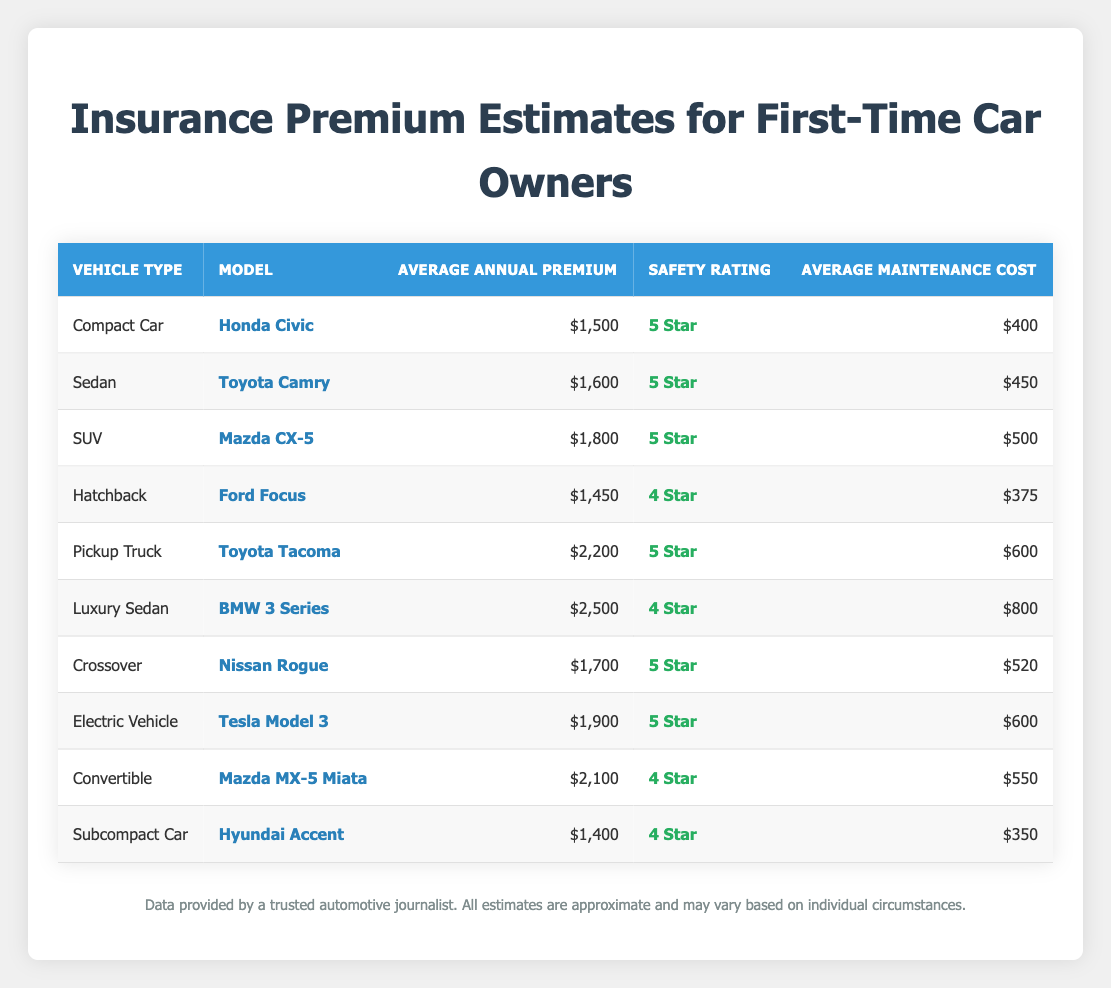What is the average annual premium for a Honda Civic? The table lists the average annual premium for the Honda Civic under the "Compact Car" category, which is $1,500.
Answer: $1,500 Which vehicle type has the lowest average annual premium? The "Subcompact Car" category lists the Hyundai Accent with an average annual premium of $1,400, which is the lowest compared to the other vehicles in the table.
Answer: Subcompact Car What is the safety rating of the Toyota Tacoma? The table shows that the Toyota Tacoma, classified as a Pickup Truck, has a safety rating of "5 Star."
Answer: 5 Star Calculate the average maintenance cost of the SUV and Crossover categories. The average maintenance cost for the Mazda CX-5 (SUV) is $500, and for the Nissan Rogue (Crossover) it is $520. The average is calculated as ($500 + $520) / 2 = $510.
Answer: $510 Is the average annual premium for the Electric Vehicle higher than that of the Compact Car? The average annual premium for the Tesla Model 3 (Electric Vehicle) is $1,900, while the premium for the Honda Civic (Compact Car) is $1,500. Since $1,900 is greater than $1,500, the statement is true.
Answer: Yes Which vehicle has the highest maintenance cost, and what is it? The table indicates the BMW 3 Series (Luxury Sedan) has the highest maintenance cost at $800.
Answer: BMW 3 Series, $800 If you add the average annual premiums of the Compact Car, Sedan, and SUV, what is the total? The average annual premiums for the Honda Civic (Compact Car), Toyota Camry (Sedan), and Mazda CX-5 (SUV) are $1,500, $1,600, and $1,800 respectively. Adding these values gives $1,500 + $1,600 + $1,800 = $4,900.
Answer: $4,900 Does the Hyundai Accent have a higher safety rating than the Ford Focus? The safety rating for the Hyundai Accent is "4 Star," while the Ford Focus also has a safety rating of "4 Star." Since both have the same rating, the statement is false.
Answer: No How much more expensive is the average annual premium of the Toyota Tacoma compared to that of the Ford Focus? The average annual premium for the Toyota Tacoma is $2,200 and for the Ford Focus it is $1,450. The difference is calculated as $2,200 - $1,450 = $750.
Answer: $750 Which vehicle category has an average annual premium of $1,800? The table states that the Mazda CX-5 falls under the SUV category, which has an average annual premium of $1,800.
Answer: SUV 